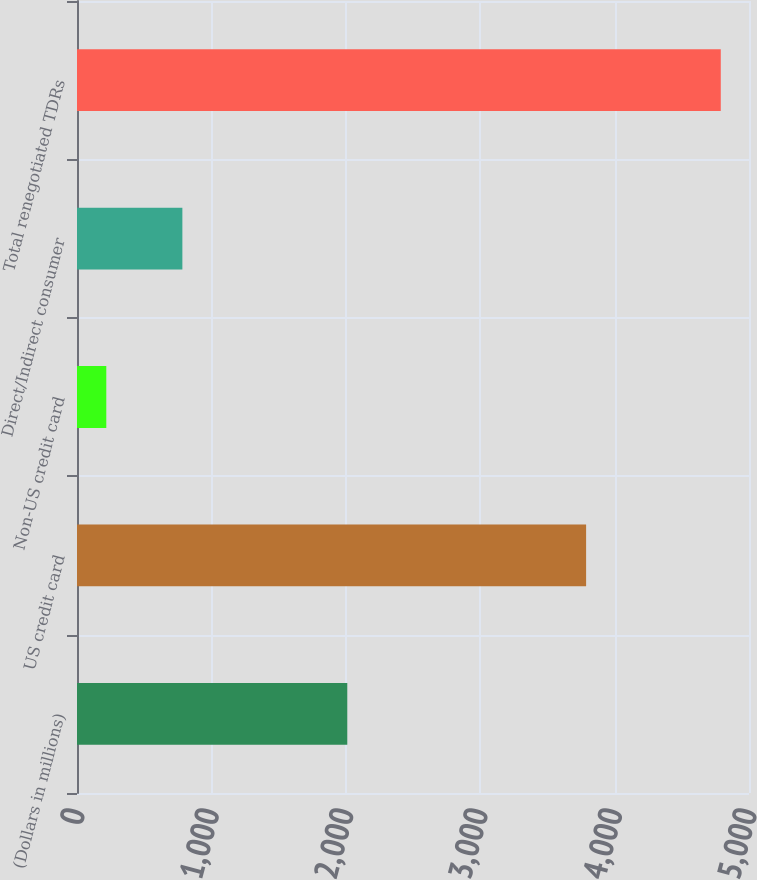<chart> <loc_0><loc_0><loc_500><loc_500><bar_chart><fcel>(Dollars in millions)<fcel>US credit card<fcel>Non-US credit card<fcel>Direct/Indirect consumer<fcel>Total renegotiated TDRs<nl><fcel>2011<fcel>3788<fcel>218<fcel>784<fcel>4790<nl></chart> 